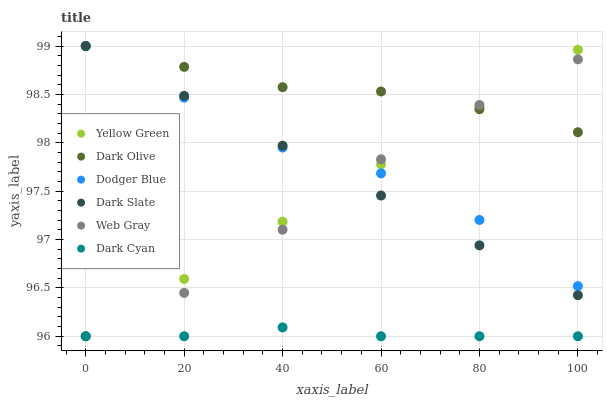Does Dark Cyan have the minimum area under the curve?
Answer yes or no. Yes. Does Dark Olive have the maximum area under the curve?
Answer yes or no. Yes. Does Yellow Green have the minimum area under the curve?
Answer yes or no. No. Does Yellow Green have the maximum area under the curve?
Answer yes or no. No. Is Yellow Green the smoothest?
Answer yes or no. Yes. Is Dodger Blue the roughest?
Answer yes or no. Yes. Is Dark Olive the smoothest?
Answer yes or no. No. Is Dark Olive the roughest?
Answer yes or no. No. Does Web Gray have the lowest value?
Answer yes or no. Yes. Does Dark Olive have the lowest value?
Answer yes or no. No. Does Dodger Blue have the highest value?
Answer yes or no. Yes. Does Yellow Green have the highest value?
Answer yes or no. No. Is Dark Cyan less than Dark Olive?
Answer yes or no. Yes. Is Dodger Blue greater than Dark Cyan?
Answer yes or no. Yes. Does Dark Olive intersect Dark Slate?
Answer yes or no. Yes. Is Dark Olive less than Dark Slate?
Answer yes or no. No. Is Dark Olive greater than Dark Slate?
Answer yes or no. No. Does Dark Cyan intersect Dark Olive?
Answer yes or no. No. 